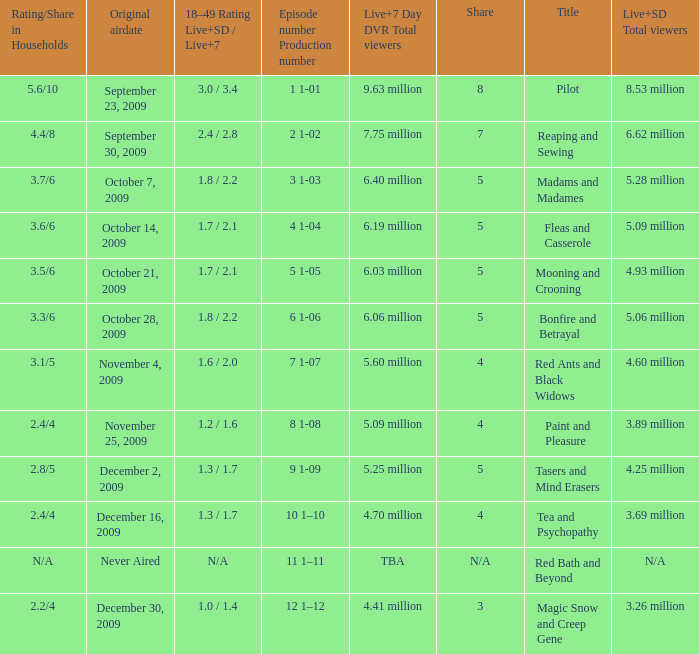How many total viewers (combined Live and SD) watched the episode with a share of 8? 9.63 million. 